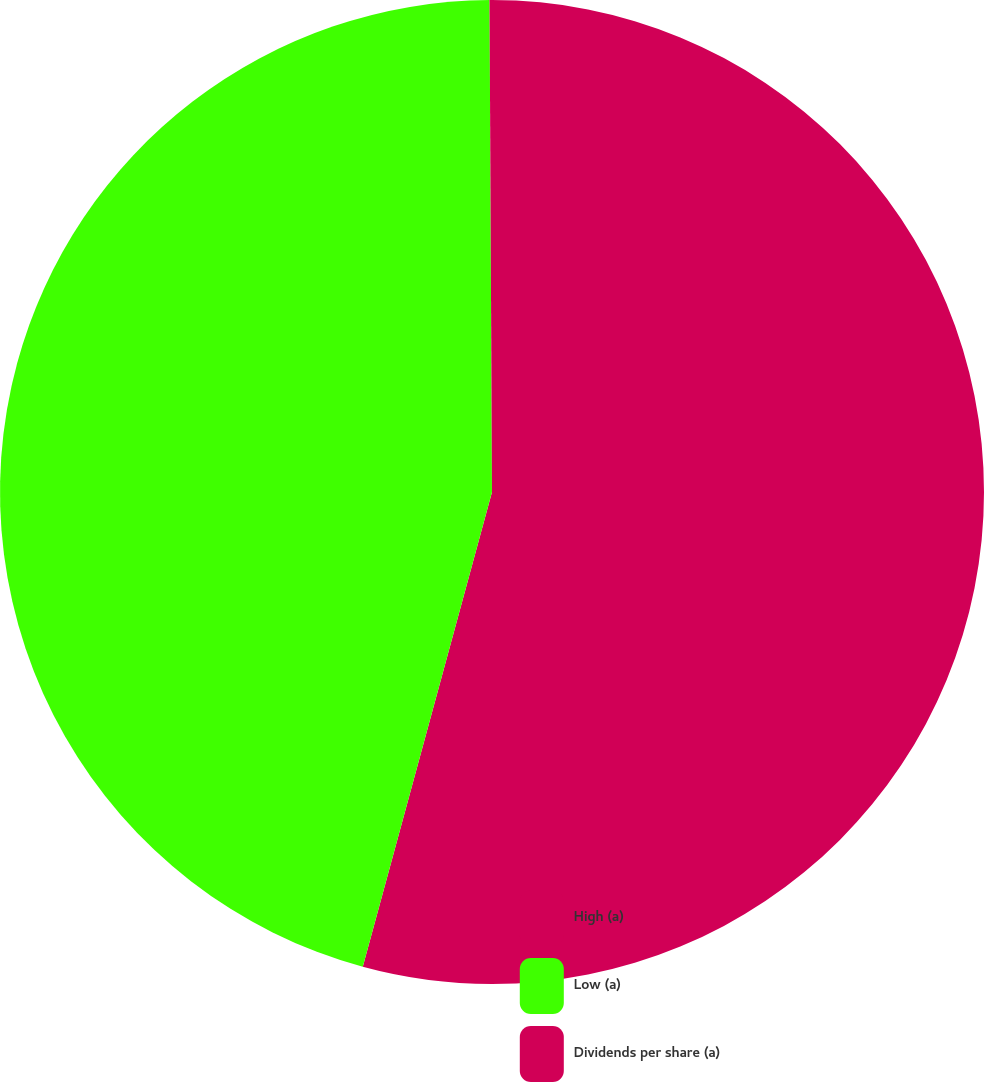Convert chart to OTSL. <chart><loc_0><loc_0><loc_500><loc_500><pie_chart><fcel>High (a)<fcel>Low (a)<fcel>Dividends per share (a)<nl><fcel>54.23%<fcel>45.69%<fcel>0.08%<nl></chart> 